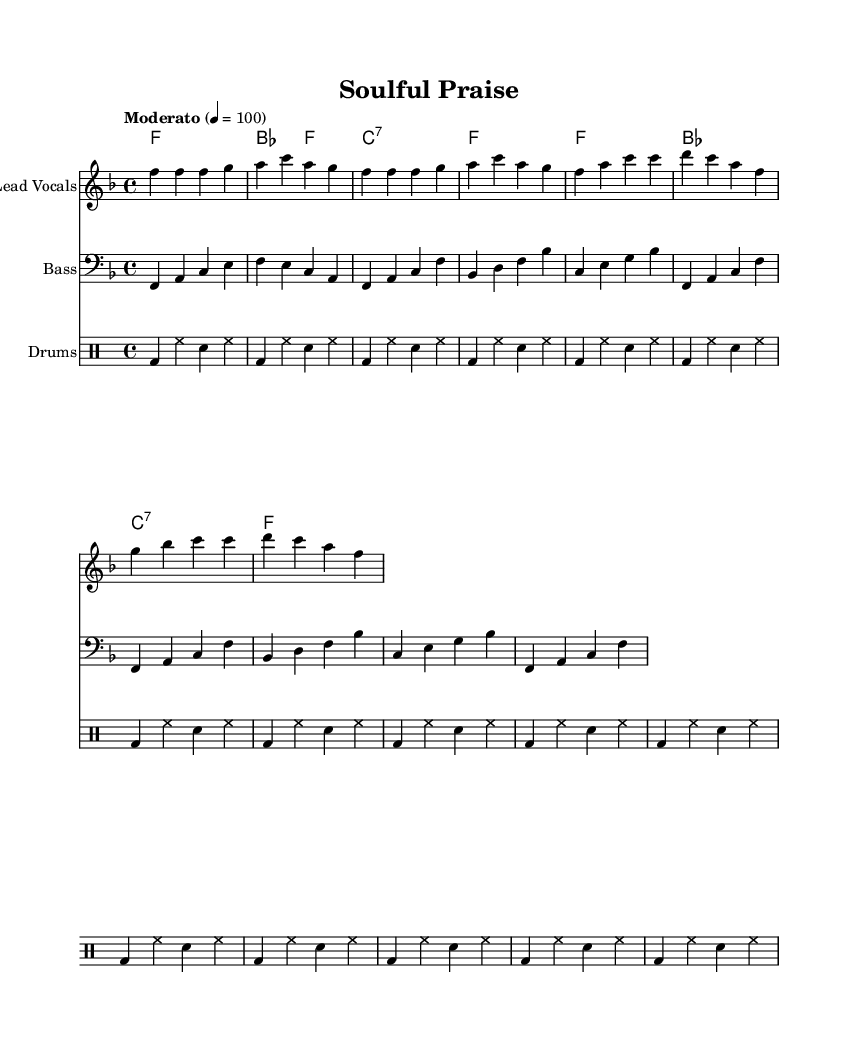What is the key signature of this music? The key signature is F major, which has one flat (B flat). This can be identified by looking at the key signature at the beginning of the music staff.
Answer: F major What is the time signature of this piece? The time signature is 4/4, which indicates that there are four beats in each measure and the quarter note gets one beat. This is shown at the beginning of the score.
Answer: 4/4 What is the tempo marking for this piece? The tempo marking is "Moderato," which suggests a moderate speed. This is specified in the tempo indication at the beginning of the score.
Answer: Moderato How many measures are there in the melody section? There are eight measures in the melody section, which can be counted by looking at the bar lines separating the measures in the melody staff.
Answer: Eight What chords are used during the chorus? The chords used during the chorus are F, B flat, C7, and F. This can be inferred by analyzing the chord symbols written above the melody and their relationship to the lyrics.
Answer: F, B flat, C7, F Which instrument plays the bass line? The bass line is played by the instrument labeled "Bass" in the score. This is clear because there is a specific staff for the bass part defined in the score.
Answer: Bass How does the drum pattern contribute to the overall rhythm? The drum pattern provides a steady beat and groove essential for dance, using kick drums and hi-hats that establish a syncopated rhythm. This can be understood by listening to the drum pattern and its role in complementing the music's pulse.
Answer: Steady groove 